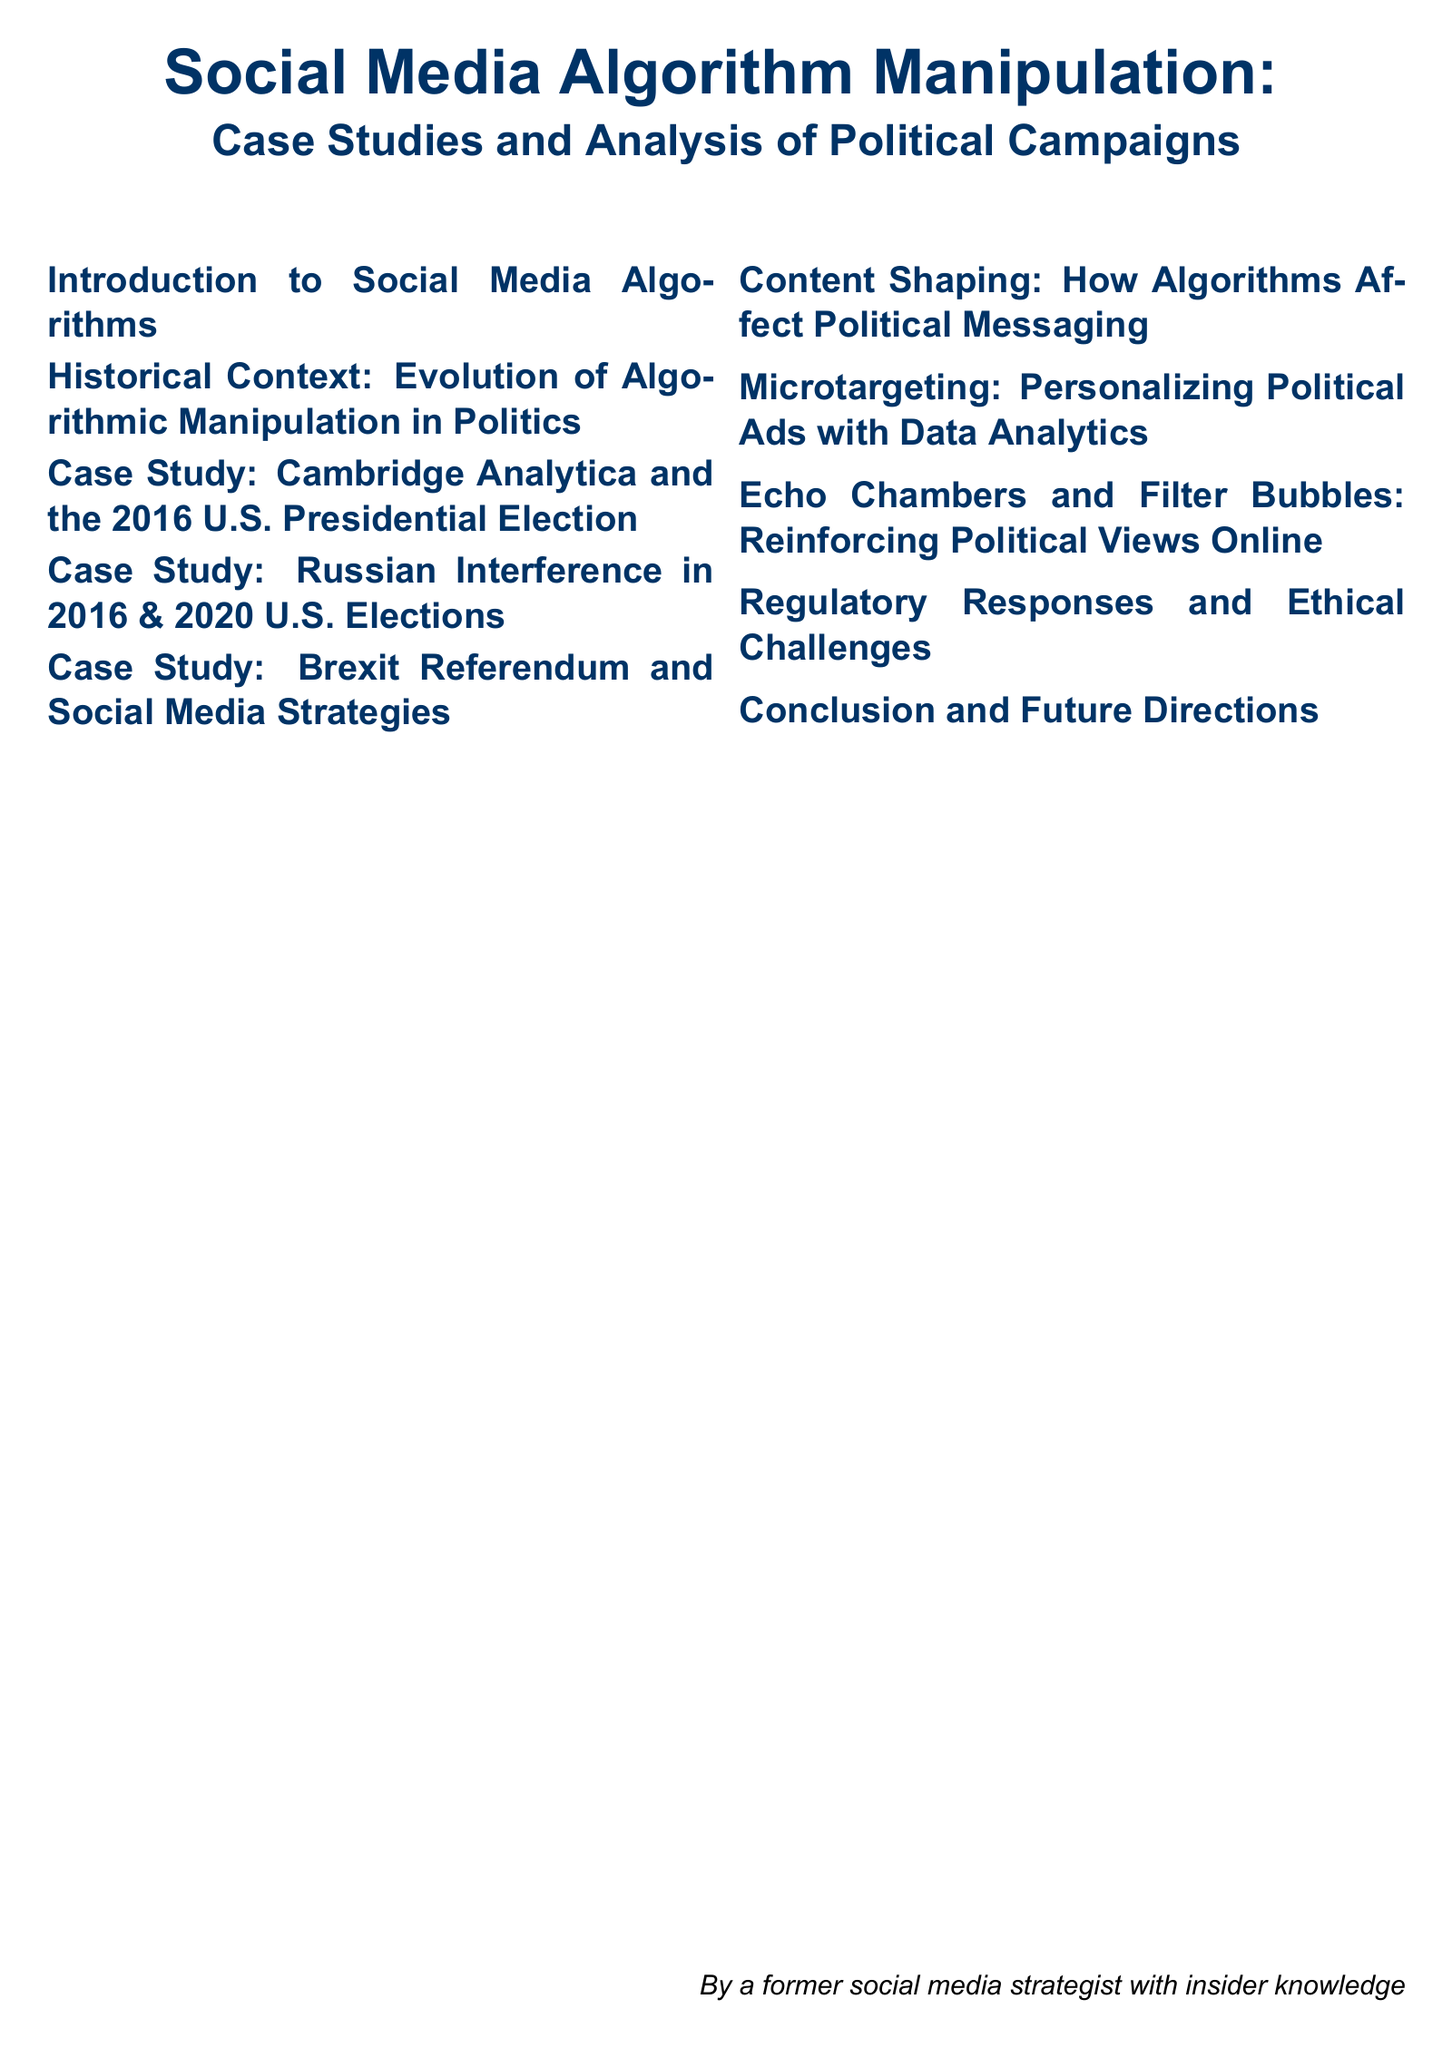What is the title of the document? The title is clearly stated at the beginning of the document.
Answer: Social Media Algorithm Manipulation: Case Studies and Analysis of Political Campaigns How many case studies are mentioned? The document lists a total of three case studies in the table of contents.
Answer: 3 What specific event does the case study regarding Cambridge Analytica pertain to? The Cambridge Analytica case study is focused on one specific election event mentioned in the document.
Answer: 2016 U.S. Presidential Election What is the last section listed in the document? The last section is mentioned at the bottom of the table of contents and focuses on future implications.
Answer: Conclusion and Future Directions Which two U.S. election years are referenced for Russian interference? The document specifically lists the years associated with Russian interference in the U.S. elections.
Answer: 2016 & 2020 What is discussed in the section titled "Content Shaping"? The section discusses a specific impact of algorithms, which is indicated in the title.
Answer: How Algorithms Affect Political Messaging What major term is associated with personalized political ads in the document? The document specifies a key term related to data analytics in the political advertising context.
Answer: Microtargeting What type of challenges are discussed in relation to regulatory responses? This is indicated in the title of a section that addresses ethical matters in the context of policy.
Answer: Ethical Challenges What does the document suggest influences online political views? The document names two phenomena that play a role in shaping online political perspectives.
Answer: Echo Chambers and Filter Bubbles 